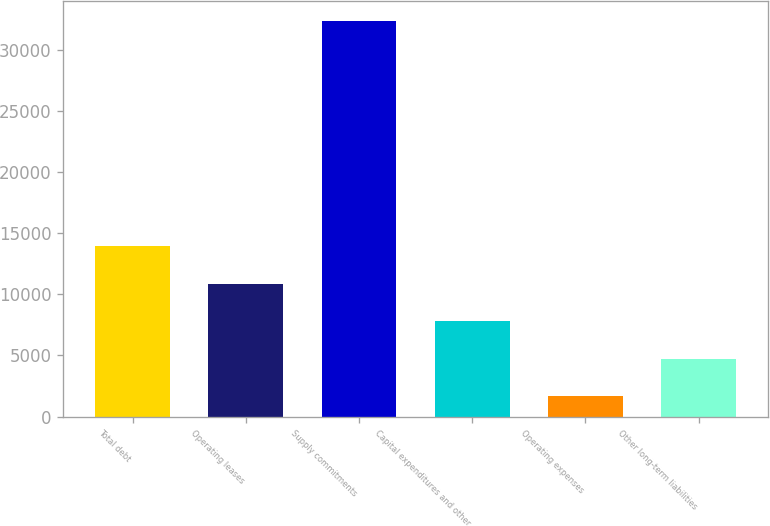<chart> <loc_0><loc_0><loc_500><loc_500><bar_chart><fcel>Total debt<fcel>Operating leases<fcel>Supply commitments<fcel>Capital expenditures and other<fcel>Operating expenses<fcel>Other long-term liabilities<nl><fcel>13956.6<fcel>10886.7<fcel>32376<fcel>7816.8<fcel>1677<fcel>4746.9<nl></chart> 